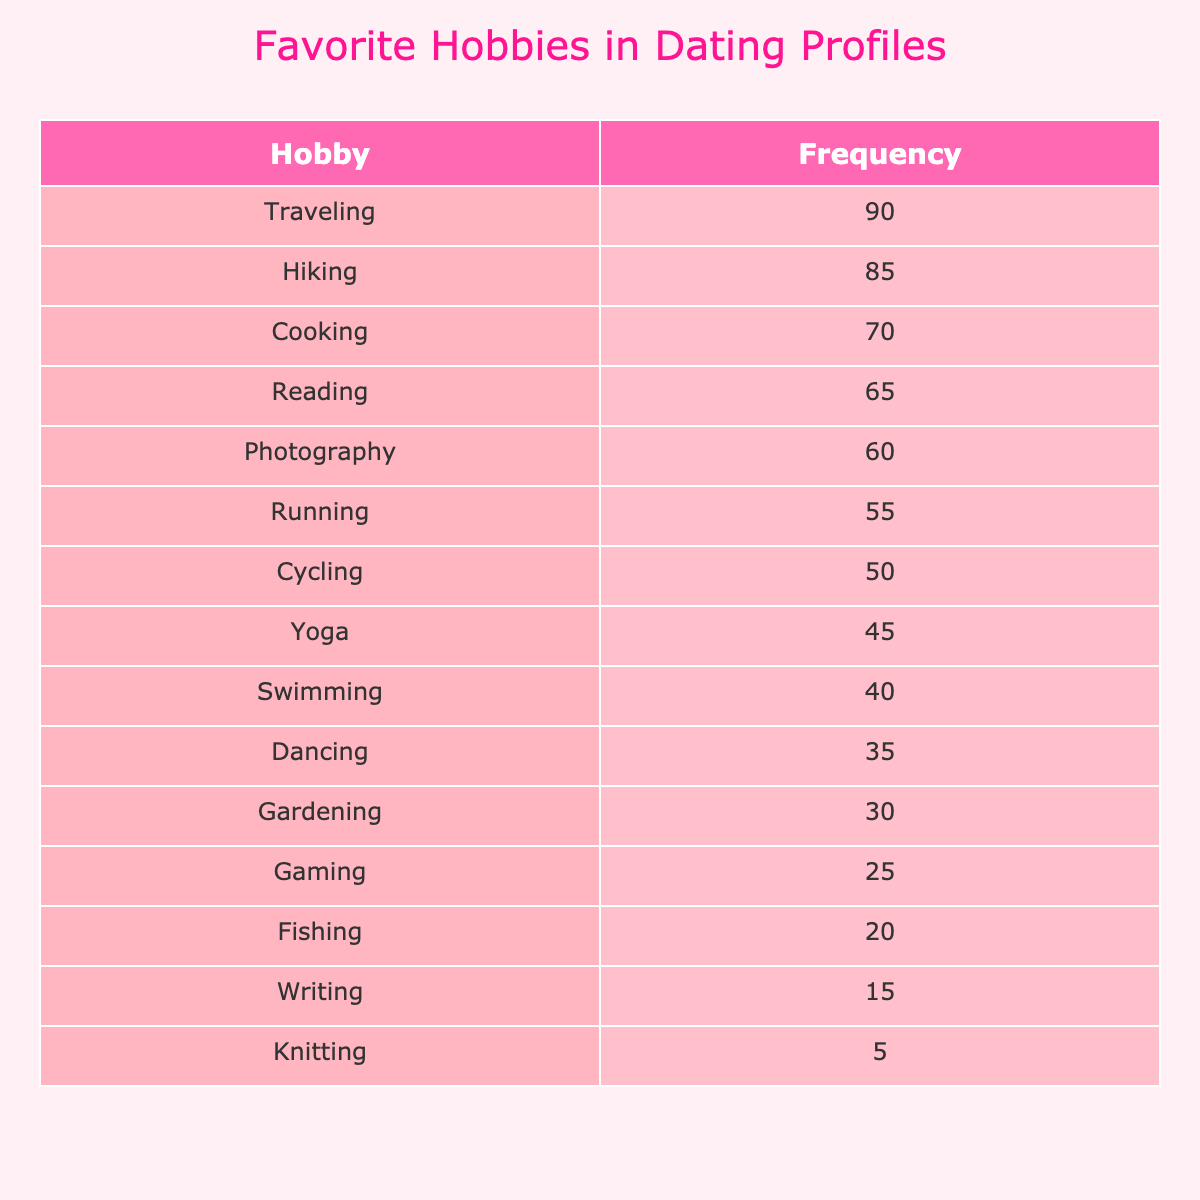What is the most frequently mentioned hobby? The table lists the hobbies in order of frequency. The hobby with the highest frequency is "Traveling" at 90.
Answer: Traveling How many people mentioned Cooking as their favorite hobby? The table shows that 70 individuals mentioned Cooking as their favorite hobby.
Answer: 70 Which hobby has a frequency that is closest to Photography? The frequency for Photography is 60. The next closest hobby is Reading, which has a frequency of 65, making it the closest.
Answer: Reading Is Fishing mentioned more often than Knitting? The frequency for Fishing is 20 and for Knitting is 5. Since 20 is greater than 5, the answer is yes.
Answer: Yes What is the combined frequency of Yoga, Swimming, and Dancing? The frequencies are Yoga: 45, Swimming: 40, and Dancing: 35. The combined frequency is 45 + 40 + 35 = 120.
Answer: 120 Which hobby has the lowest frequency, and how many people mentioned it? The lowest frequency in the table is for Knitting with a frequency of 5.
Answer: Knitting, 5 If we consider only the top three hobbies, what is their average frequency? The top three hobbies are Traveling (90), Hiking (85), and Cooking (70). Their average frequency is (90 + 85 + 70) / 3 = 81.67.
Answer: 81.67 Is there a hobby mentioned by more than 80 people? Looking at the table, Traveling (90) and Hiking (85) are the only hobbies with a frequency greater than 80, hence the answer is yes.
Answer: Yes What is the difference in frequency between Running and Cycling? The frequency for Running is 55, and for Cycling is 50. The difference is 55 - 50 = 5.
Answer: 5 